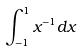Convert formula to latex. <formula><loc_0><loc_0><loc_500><loc_500>\int _ { - 1 } ^ { 1 } x ^ { - 1 } d x</formula> 